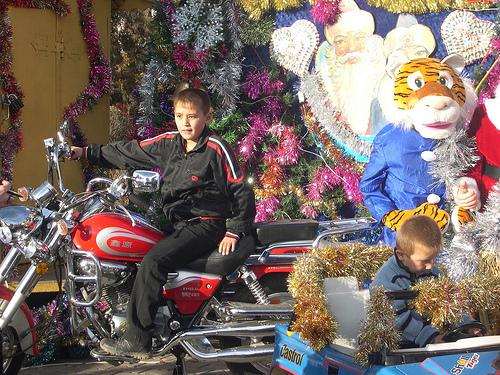Question: who is in the blue car?
Choices:
A. Girl.
B. A boy.
C. Woman.
D. Man.
Answer with the letter. Answer: B Question: what stuffed animal is in the picture?
Choices:
A. A bear.
B. A cat.
C. A rooster.
D. A tiger.
Answer with the letter. Answer: D Question: how many people are in the picture?
Choices:
A. 3.
B. 4.
C. 5.
D. 2.
Answer with the letter. Answer: D Question: what color are the boy on the bikes shoes?
Choices:
A. Blue.
B. Pink.
C. White.
D. Black.
Answer with the letter. Answer: D Question: what is wrapped around the toy car?
Choices:
A. Garland.
B. Paper.
C. Ribbon.
D. String.
Answer with the letter. Answer: A 